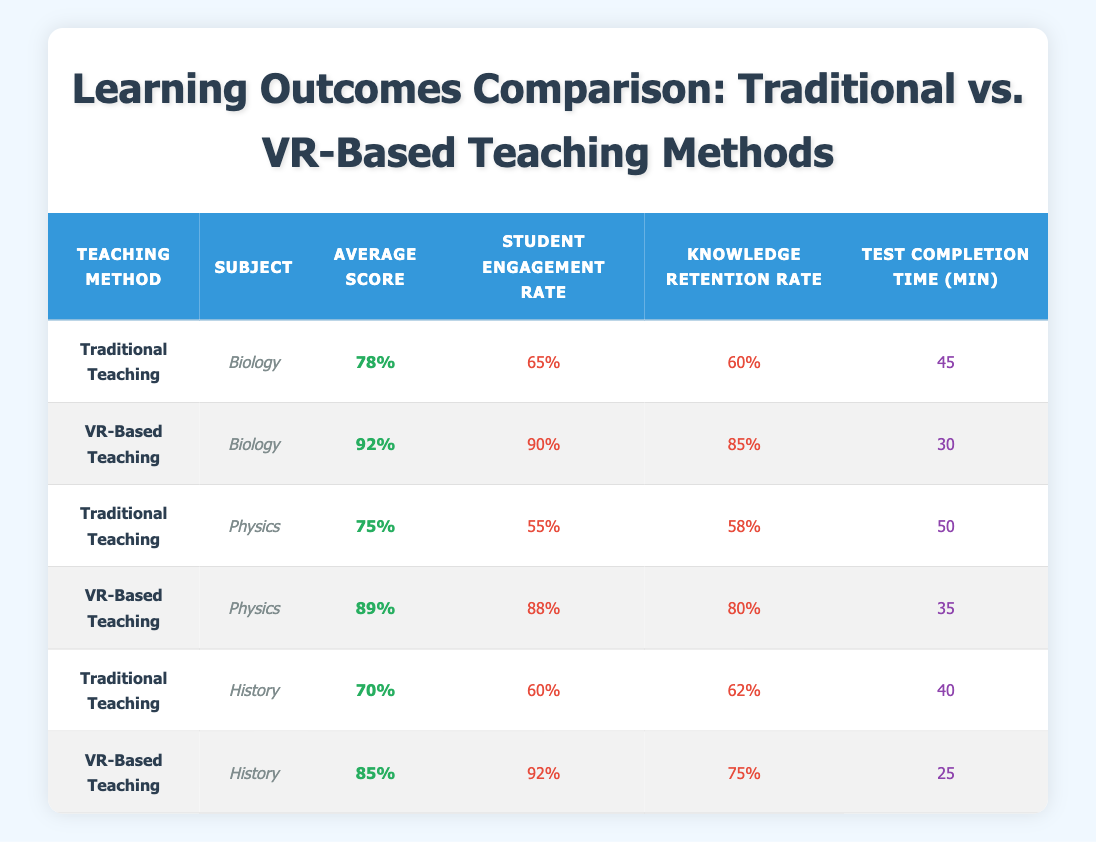What is the average score for the VR-Based Teaching method in Biology? The average score for VR-Based Teaching under Biology is listed directly in the table as 92%.
Answer: 92% How much time, on average, do students take to complete tests in traditional teaching methods compared to VR-based methods in History? The traditional teaching method for History has a test completion time of 40 minutes, while the VR-based method has a completion time of 25 minutes; comparing the two gives 40 - 25 = 15 minutes difference.
Answer: 15 minutes What is the student engagement rate for Traditional Teaching in Physics? The table shows that the student engagement rate for Traditional Teaching in Physics is 55%.
Answer: 55% Is the knowledge retention rate higher for VR-Based Teaching in Biology compared to Traditional Teaching in the same subject? The knowledge retention rate for VR-Based Teaching in Biology is 85%, while for Traditional Teaching, it is 60%; since 85% is greater than 60%, this statement is true.
Answer: Yes If we consider all subjects, what is the highest average score achieved by any teaching method? The average scores for each teaching method in subjects indicate that the highest score is 92%, achieved by VR-Based Teaching in Biology.
Answer: 92% What is the average student engagement rate across all VR-Based Teaching methods? The engagement rates for VR-Based Teaching are 90%, 88%, and 92% for Biology, Physics, and History respectively. To find the average: (90 + 88 + 92) / 3 = 90%.
Answer: 90% Which teaching method has better knowledge retention in History, and by how much? The knowledge retention for VR-Based Teaching in History is 75%, whereas for Traditional Teaching, it is 62%. The difference is 75 - 62 = 13%.
Answer: VR-Based Teaching has better retention by 13% How does the test completion time compare between the two teaching methods in Physics? For Traditional Teaching in Physics, the test completion time is 50 minutes, while for VR-Based Teaching it is 35 minutes. The difference shows that VR takes 15 minutes less compared to Traditional Teaching.
Answer: VR-Based Teaching is 15 minutes faster Is it true that all VR-Based Teaching methods have higher average scores than their Traditional counterparts? By reviewing the average scores, VR-Based Teaching has scores of 92% (Biology), 89% (Physics), and 85% (History). The corresponding scores for Traditional Teaching are 78%, 75%, and 70%, confirming that all VR scores are higher.
Answer: Yes 